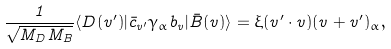Convert formula to latex. <formula><loc_0><loc_0><loc_500><loc_500>\frac { 1 } { \sqrt { M _ { D } M _ { B } } } \langle D ( v ^ { \prime } ) | \bar { c } _ { v ^ { \prime } } \gamma _ { \alpha } b _ { v } | \bar { B } ( v ) \rangle = \xi ( v ^ { \prime } \cdot v ) ( v + v ^ { \prime } ) _ { \alpha } ,</formula> 